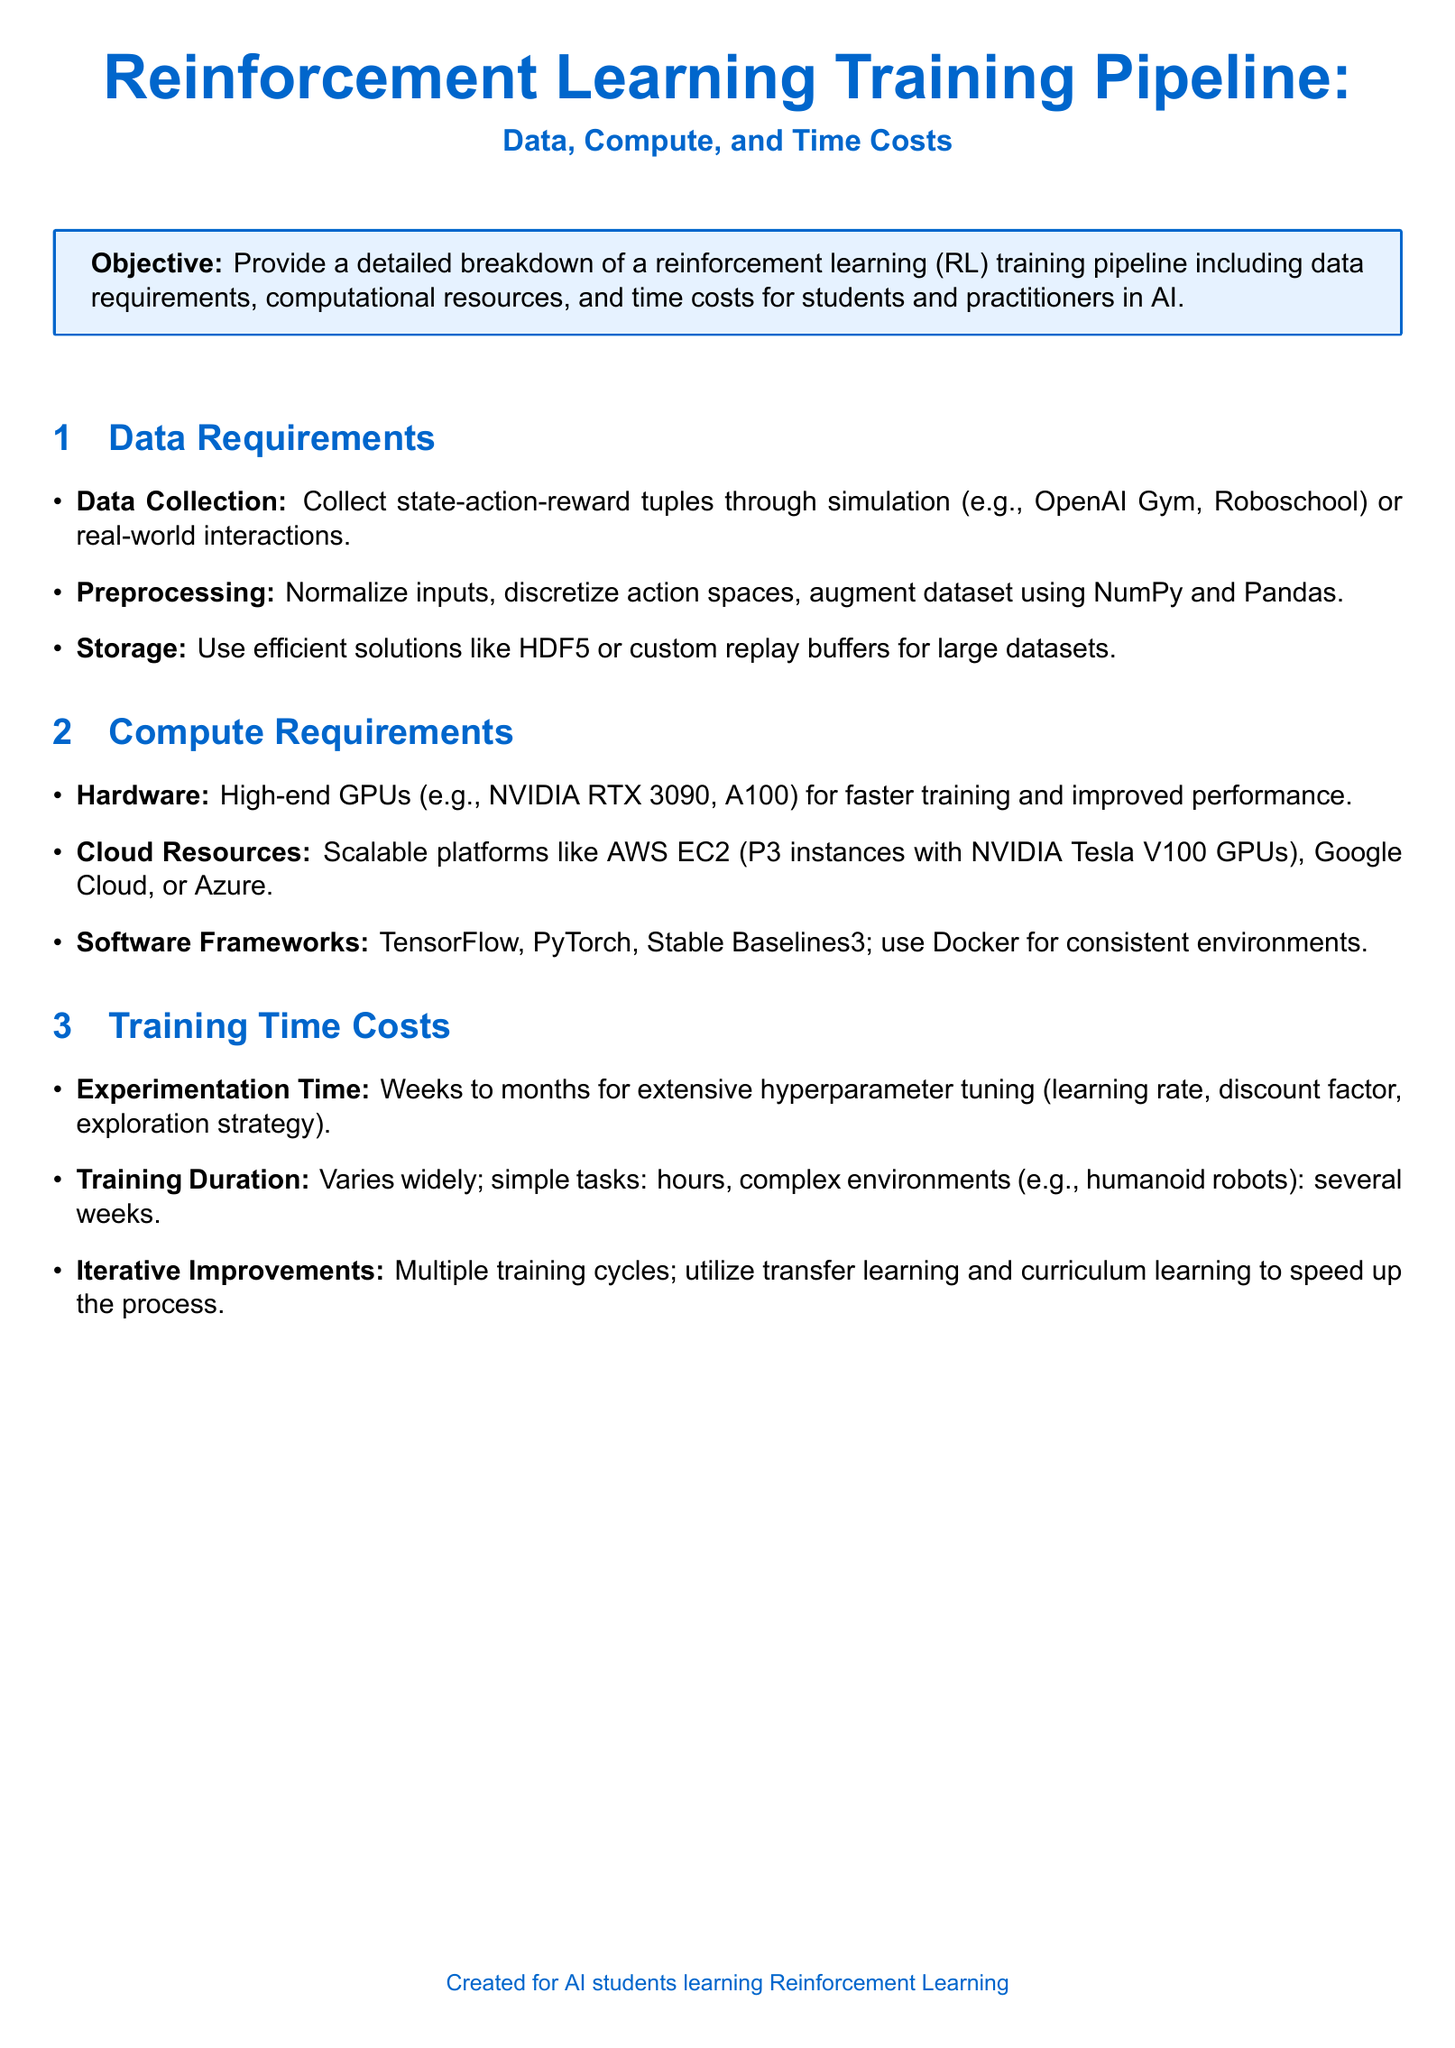What is the objective of the document? The objective is detailed in the introduction, emphasizing the breakdown of the reinforcement learning training pipeline.
Answer: Provide a detailed breakdown of a reinforcement learning training pipeline including data requirements, computational resources, and time costs What type of data collection methods are mentioned? The document specifies data collection methods in the requirements section, highlighting simulations and real-world interactions.
Answer: Simulation or real-world interactions What is the recommended hardware for training? The compute requirements section specifically mentions high-end GPUs for efficient training processes.
Answer: NVIDIA RTX 3090, A100 What platforms are suggested for cloud resources? The document lists various scalable platforms under compute requirements, indicating options for cloud services.
Answer: AWS EC2, Google Cloud, or Azure How long can experimentation time take? The training time costs section provides an estimated range for how long experimentation may require.
Answer: Weeks to months What training duration is expected for simple tasks? The document gives a timeframe for training durations according to task complexity in the training time costs section.
Answer: Hours What are the two specific learning techniques mentioned for iterative improvements? In the training time costs section, the document highlights methods to accelerate training cycles through improved strategies.
Answer: Transfer learning and curriculum learning What data storage solutions are mentioned? The data requirements section outlines options for efficient storage solutions tailored to large datasets.
Answer: HDF5 or custom replay buffers 